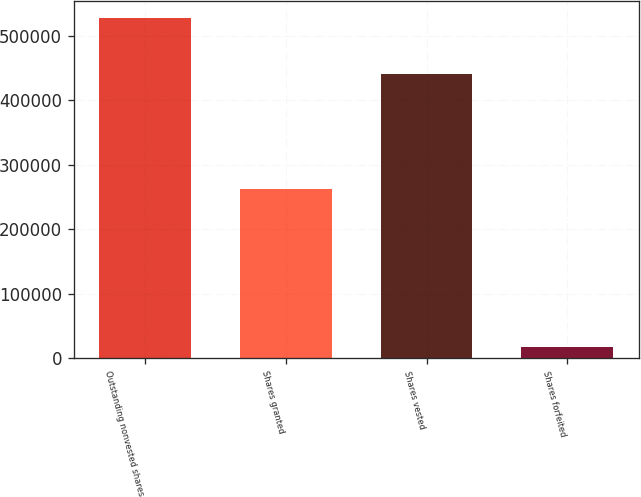Convert chart to OTSL. <chart><loc_0><loc_0><loc_500><loc_500><bar_chart><fcel>Outstanding nonvested shares<fcel>Shares granted<fcel>Shares vested<fcel>Shares forfeited<nl><fcel>527176<fcel>262655<fcel>440348<fcel>17394<nl></chart> 